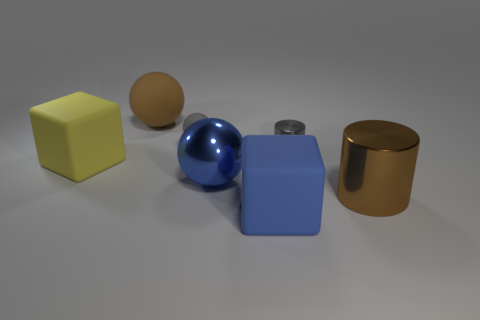Subtract all matte balls. How many balls are left? 1 Add 2 big blue shiny spheres. How many objects exist? 9 Subtract all gray cylinders. How many cylinders are left? 1 Subtract all blue spheres. How many brown cylinders are left? 1 Subtract all spheres. How many objects are left? 4 Subtract 1 blocks. How many blocks are left? 1 Subtract all blue matte cubes. Subtract all small cylinders. How many objects are left? 5 Add 3 large matte balls. How many large matte balls are left? 4 Add 7 large blue metallic objects. How many large blue metallic objects exist? 8 Subtract 0 blue cylinders. How many objects are left? 7 